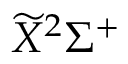<formula> <loc_0><loc_0><loc_500><loc_500>\widetilde { X } ^ { 2 } \Sigma ^ { + }</formula> 